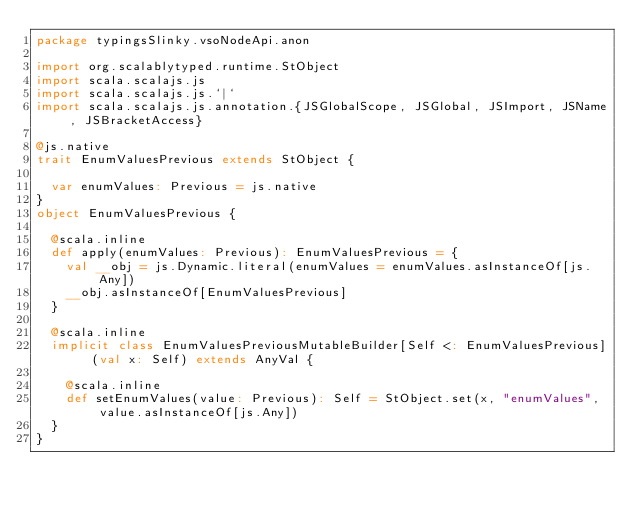Convert code to text. <code><loc_0><loc_0><loc_500><loc_500><_Scala_>package typingsSlinky.vsoNodeApi.anon

import org.scalablytyped.runtime.StObject
import scala.scalajs.js
import scala.scalajs.js.`|`
import scala.scalajs.js.annotation.{JSGlobalScope, JSGlobal, JSImport, JSName, JSBracketAccess}

@js.native
trait EnumValuesPrevious extends StObject {
  
  var enumValues: Previous = js.native
}
object EnumValuesPrevious {
  
  @scala.inline
  def apply(enumValues: Previous): EnumValuesPrevious = {
    val __obj = js.Dynamic.literal(enumValues = enumValues.asInstanceOf[js.Any])
    __obj.asInstanceOf[EnumValuesPrevious]
  }
  
  @scala.inline
  implicit class EnumValuesPreviousMutableBuilder[Self <: EnumValuesPrevious] (val x: Self) extends AnyVal {
    
    @scala.inline
    def setEnumValues(value: Previous): Self = StObject.set(x, "enumValues", value.asInstanceOf[js.Any])
  }
}
</code> 